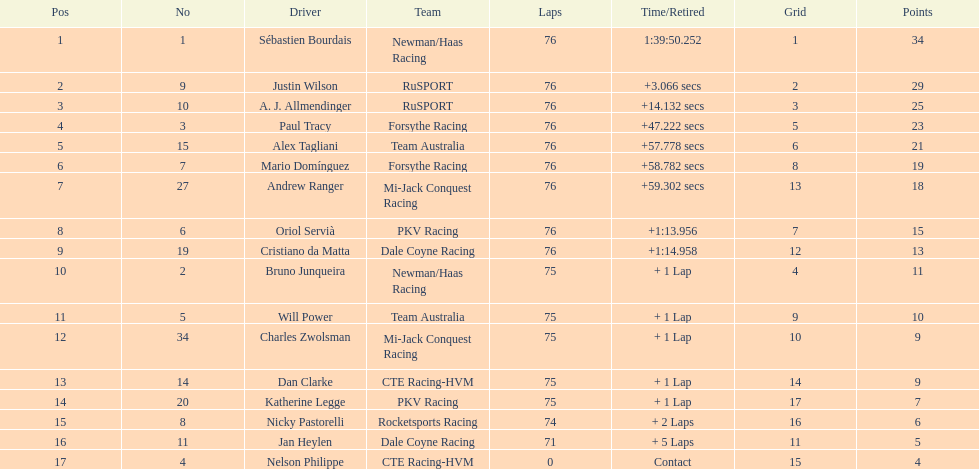What driver earned the most points? Sebastien Bourdais. 